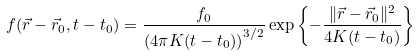Convert formula to latex. <formula><loc_0><loc_0><loc_500><loc_500>f ( \vec { r } - \vec { r } _ { 0 } , t - t _ { 0 } ) = \frac { f _ { 0 } } { \left ( 4 \pi K ( t - t _ { 0 } ) \right ) ^ { 3 / 2 } } \exp \left \{ - \frac { \| \vec { r } - \vec { r } _ { 0 } \| ^ { 2 } } { 4 K ( t - t _ { 0 } ) } \right \}</formula> 